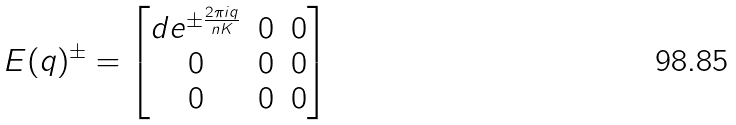Convert formula to latex. <formula><loc_0><loc_0><loc_500><loc_500>E ( q ) ^ { \pm } = \begin{bmatrix} d e ^ { \pm \frac { 2 \pi i q } { n K } } & 0 & 0 \\ 0 & 0 & 0 \\ 0 & 0 & 0 \end{bmatrix}</formula> 